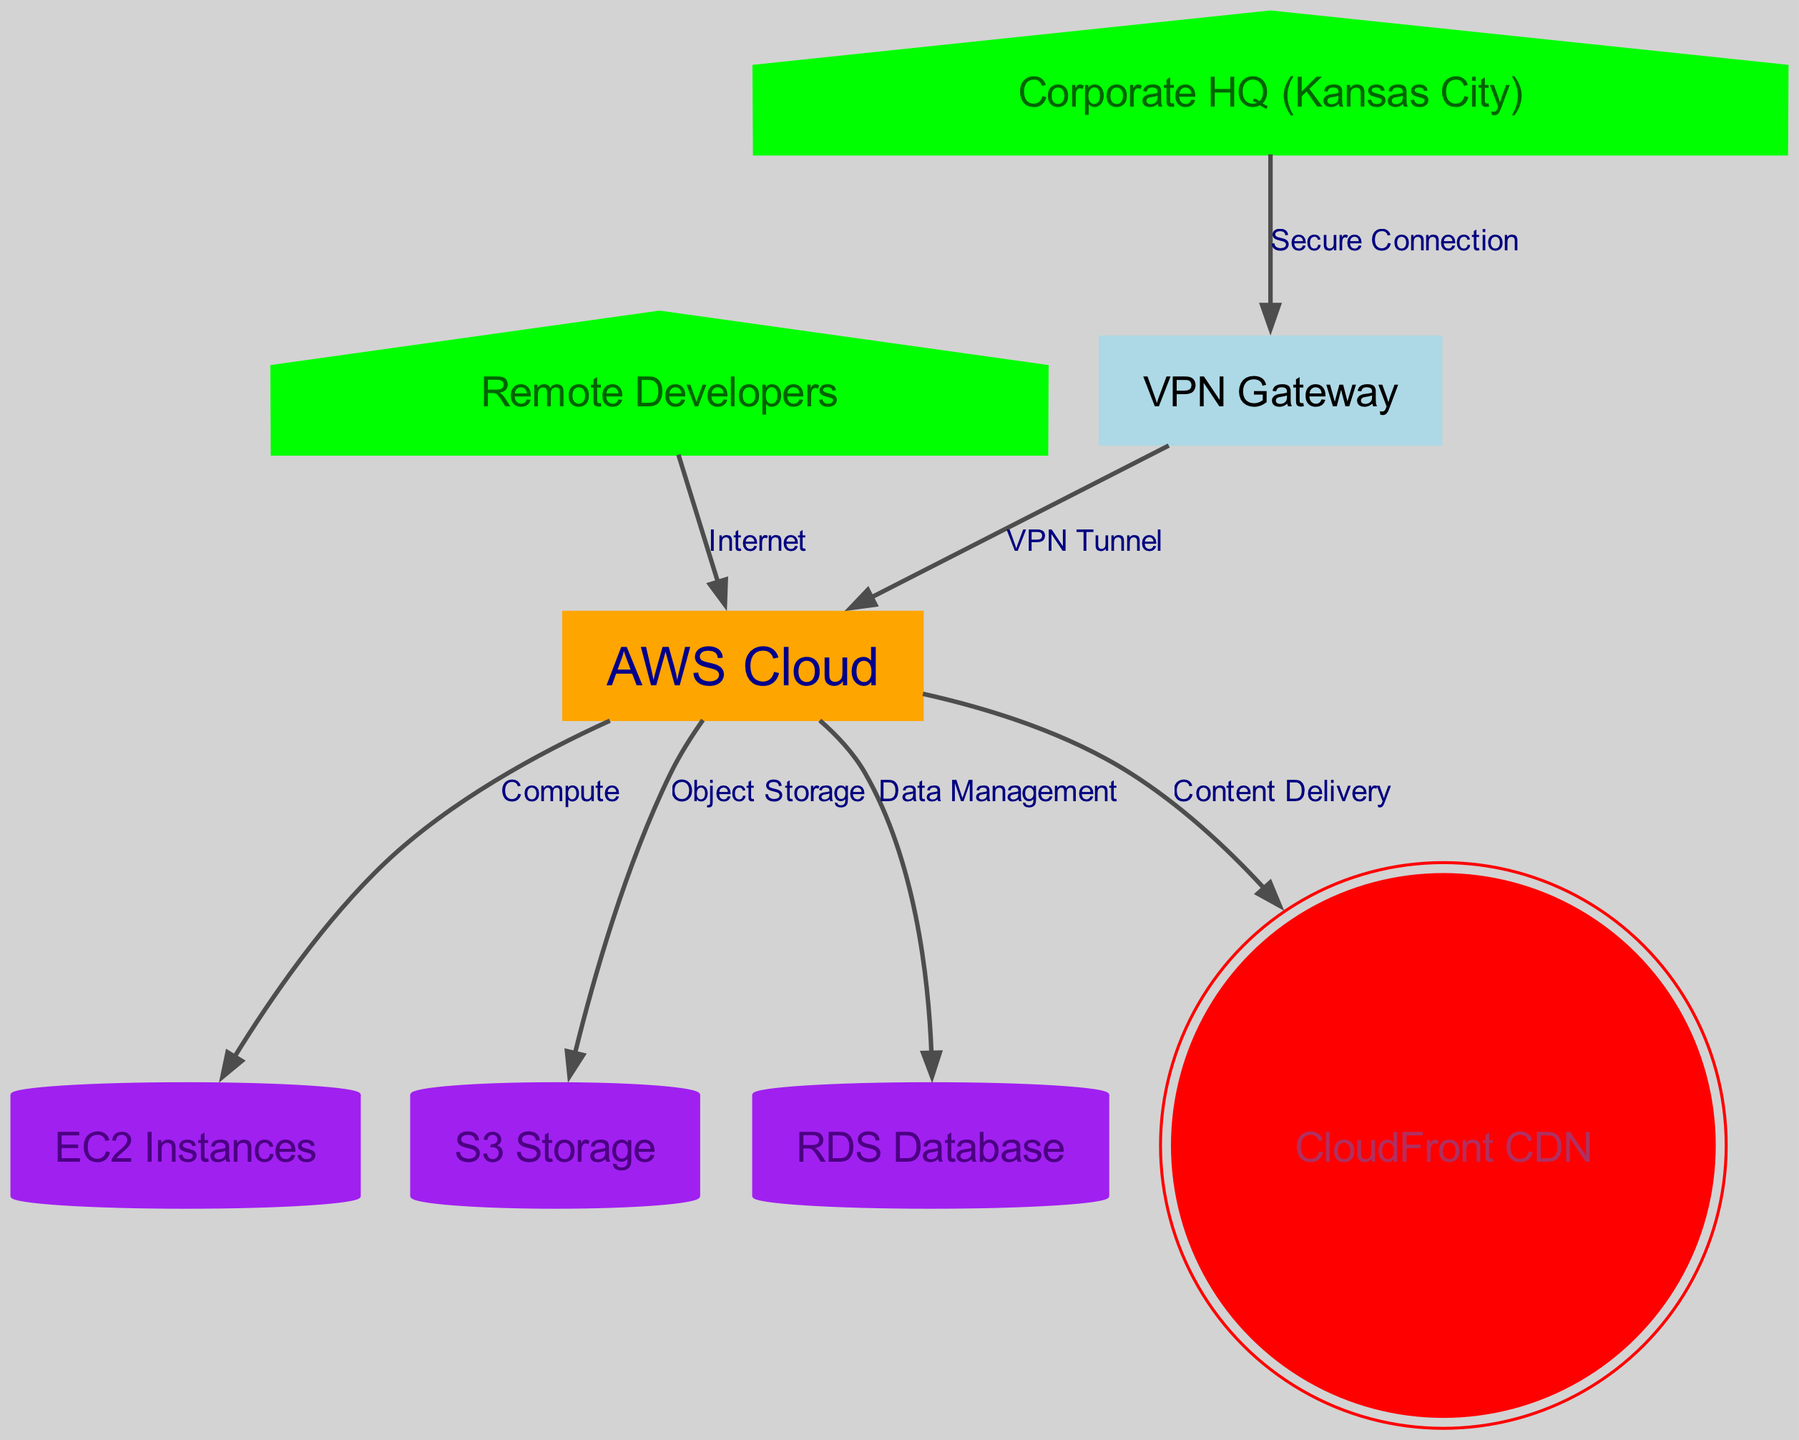What is the label of node 1? Node 1 is designated as "AWS Cloud," as indicated in the node's attributes in the diagram data provided.
Answer: AWS Cloud How many total nodes are there in the diagram? The nodes listed in the data provide a total of 8 individual entities identified by unique IDs, ranging from 1 to 8.
Answer: 8 What type of connection exists between Corporate HQ and the VPN Gateway? The diagram edge shows a "Secure Connection" between node 2 (Corporate HQ) and node 8 (VPN Gateway), as specified in the edges of the diagram.
Answer: Secure Connection Which node connects CloudFront CDN to the AWS Cloud? The edges indicate a direct connection from node 1 (AWS Cloud) to node 7 (CloudFront CDN), with the label "Content Delivery," identifying their relationship.
Answer: Content Delivery What is the relationship between the Remote Developers and AWS Cloud? The relationship is established through an "Internet" connection from node 3 (Remote Developers) to node 1 (AWS Cloud), depicted in the edge data of the diagram.
Answer: Internet How many connections does the AWS Cloud node have? By reviewing the edges from node 1 (AWS Cloud), we find that it connects to four different nodes: EC2 Instances, S3 Storage, RDS Database, and CloudFront CDN, totaling 4 connections.
Answer: 4 Which node does the VPN Gateway connect to through a tunnel? The edge data shows that the VPN Gateway (node 8) establishes a "VPN Tunnel" connection to node 1, which is the AWS Cloud.
Answer: AWS Cloud What type of database is represented in the diagram? The diagram identifies the database as an "RDS Database," which is node 6, characterized in the data provided.
Answer: RDS Database What is the main purpose of the connection between AWS Cloud and EC2 Instances? The purpose of the connection is for "Compute," as labeled in the edge connecting AWS Cloud (node 1) to EC2 Instances (node 4).
Answer: Compute 